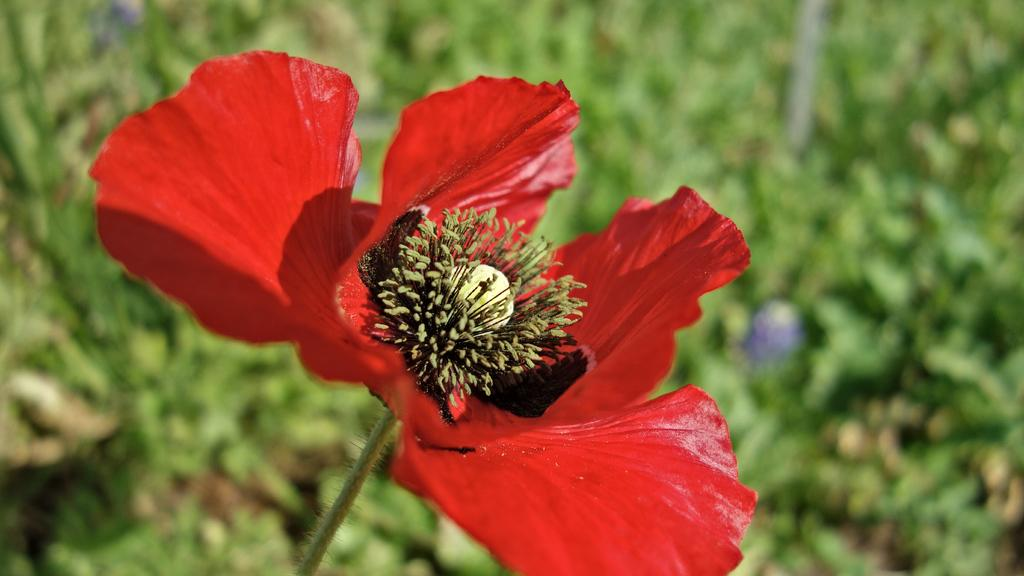What type of flower is present in the image? There is a red color flower in the image. What can be seen on the flower in the image? Pollen grains are visible in the image. How would you describe the background of the image? The background of the image is blurry. How does the zephyr affect the movement of the boats in the image? There are no boats present in the image, and therefore no movement of boats can be observed. 